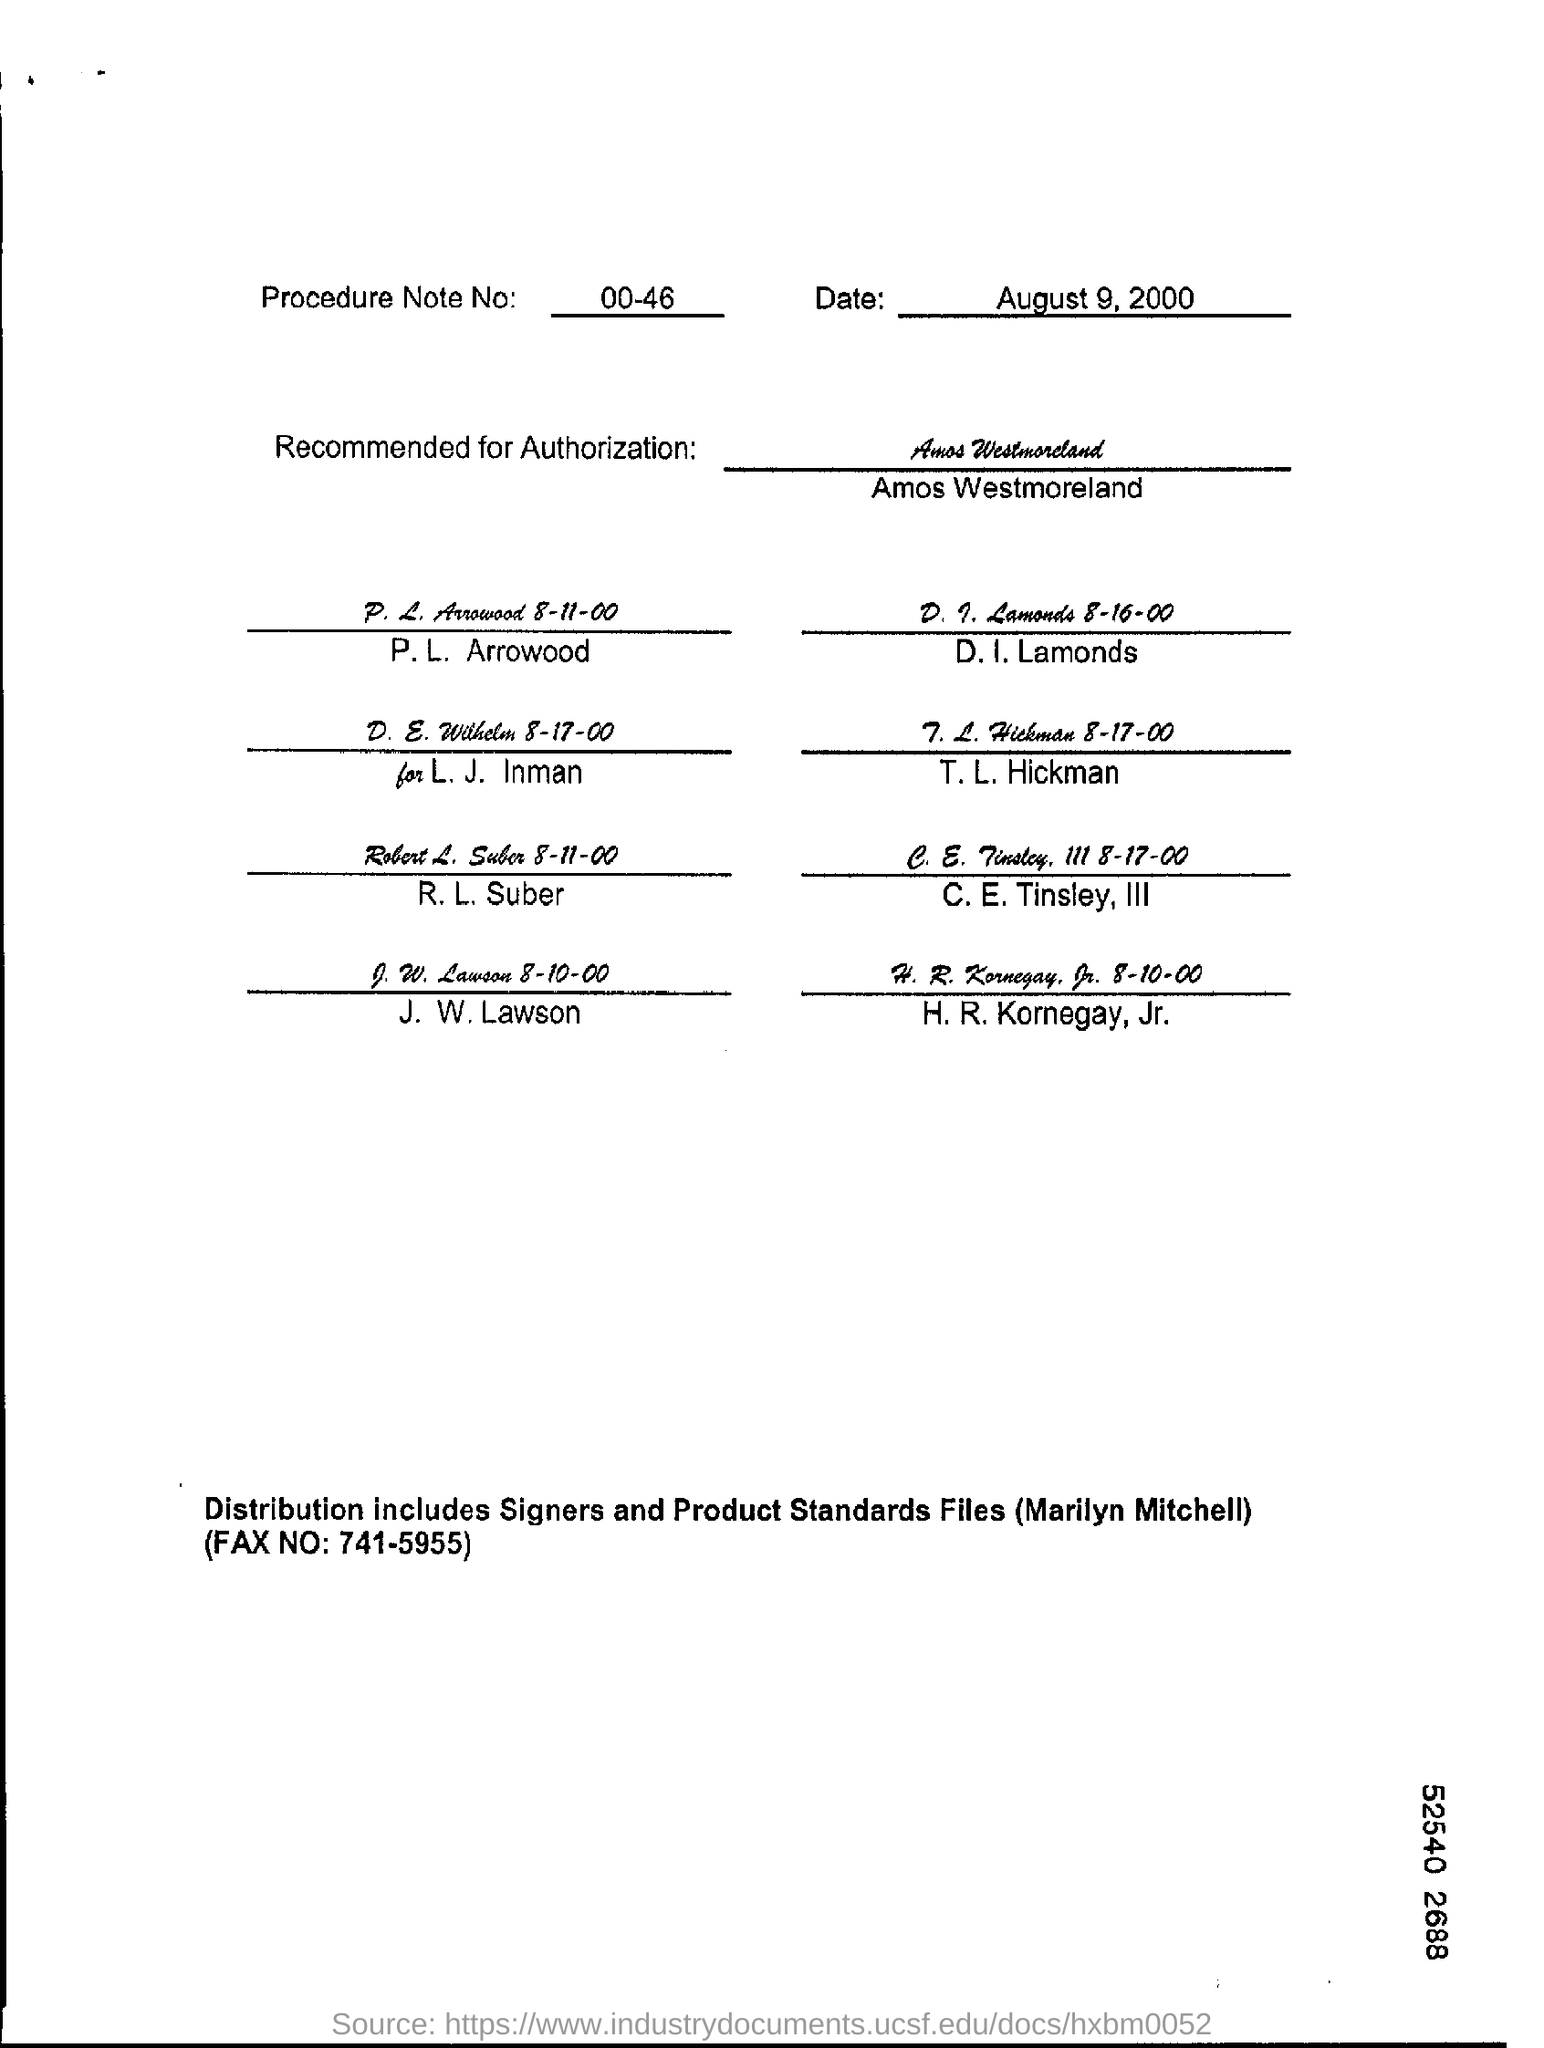What is the Procedure Note No?
Offer a very short reply. 00-46. When is the form dated?
Your answer should be compact. August 9, 2000. 